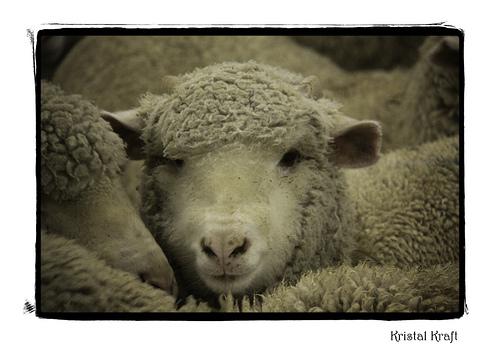What two kinds of animals are here?
Write a very short answer. Sheep. Have these animals been sheared recently?
Concise answer only. Yes. Is this a color photograph?
Be succinct. Yes. Does this animal have an ear tag?
Be succinct. No. 